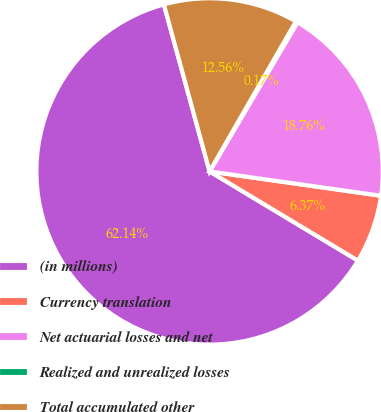Convert chart. <chart><loc_0><loc_0><loc_500><loc_500><pie_chart><fcel>(in millions)<fcel>Currency translation<fcel>Net actuarial losses and net<fcel>Realized and unrealized losses<fcel>Total accumulated other<nl><fcel>62.13%<fcel>6.37%<fcel>18.76%<fcel>0.17%<fcel>12.56%<nl></chart> 